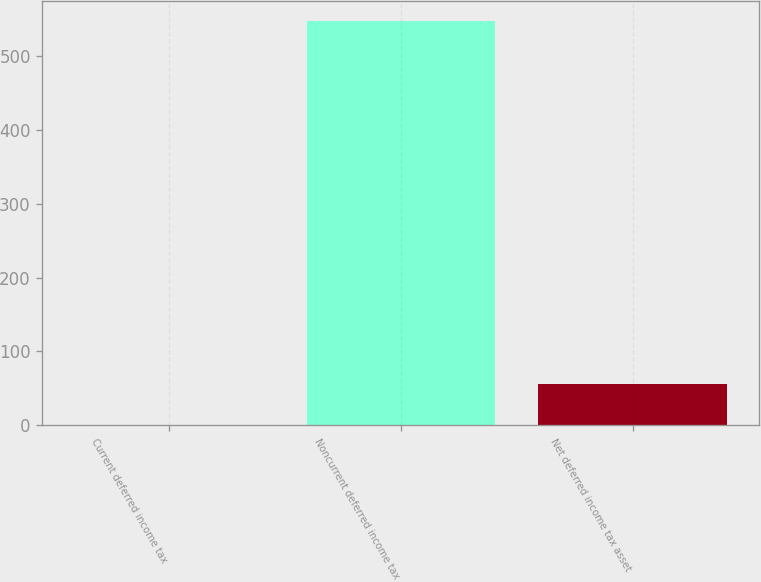Convert chart. <chart><loc_0><loc_0><loc_500><loc_500><bar_chart><fcel>Current deferred income tax<fcel>Noncurrent deferred income tax<fcel>Net deferred income tax asset<nl><fcel>1<fcel>548<fcel>55.7<nl></chart> 